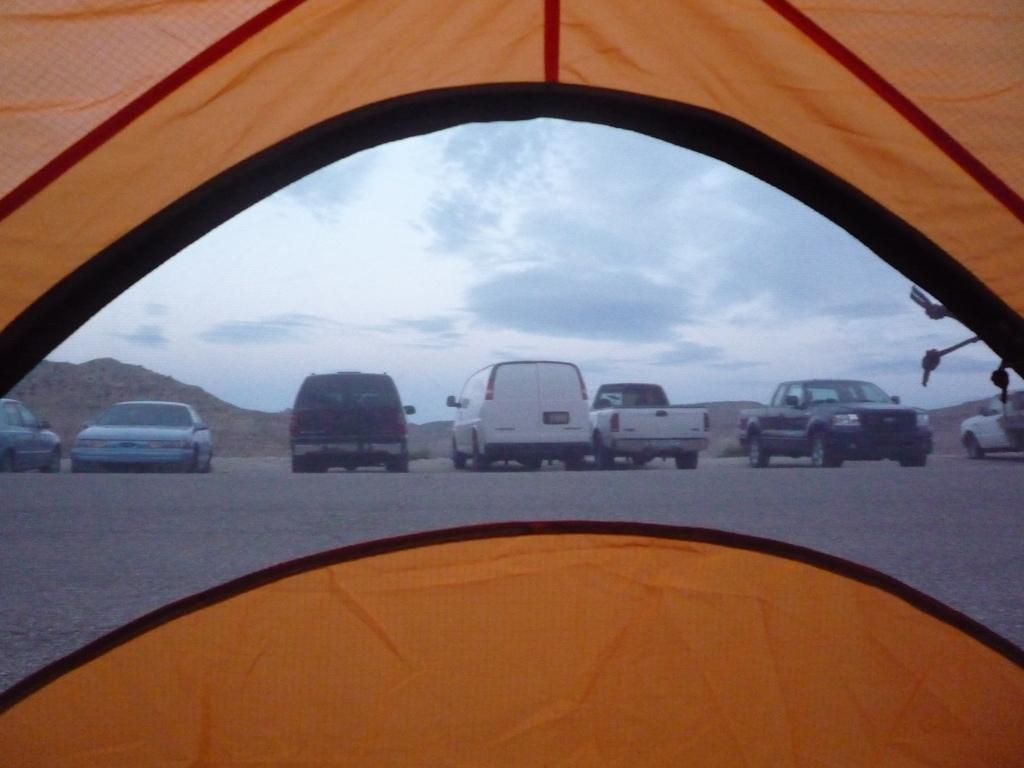Can you describe this image briefly? In this picture we can see a tent, in the background we can find few cars, hills and clouds. 